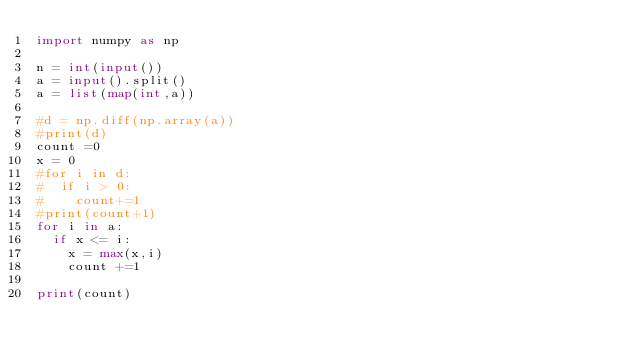<code> <loc_0><loc_0><loc_500><loc_500><_Python_>import numpy as np

n = int(input())
a = input().split()
a = list(map(int,a))

#d = np.diff(np.array(a))
#print(d)
count =0
x = 0
#for i in d:
#  if i > 0:
#    count+=1
#print(count+1)    
for i in a:
  if x <= i:
    x = max(x,i)
    count +=1
    
print(count) </code> 